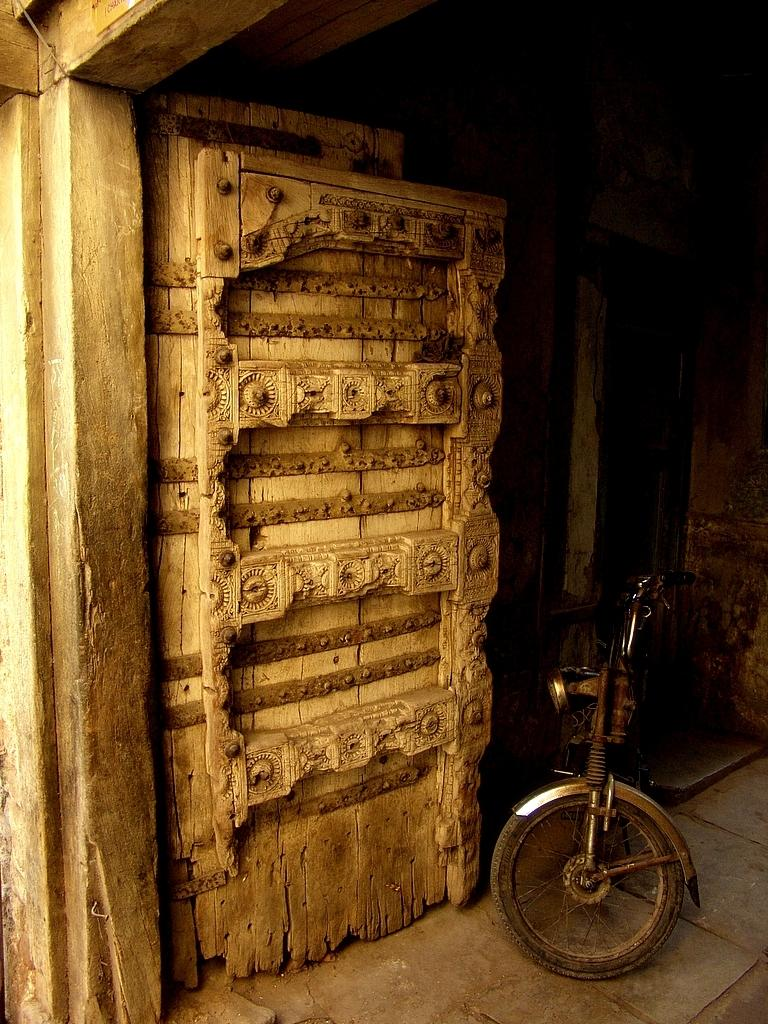What type of door is visible in the image? There is a wooden door in the image. What is parked on the floor in the image? There is a vehicle parked on the floor in the image. What type of wood is used to make the clouds in the image? There are no clouds present in the image, and therefore no wood is used to make them. What kind of test is being conducted in the image? There is no test being conducted in the image; it features a wooden door and a parked vehicle. 